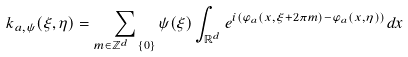Convert formula to latex. <formula><loc_0><loc_0><loc_500><loc_500>k _ { a , \psi } ( \xi , \eta ) = \sum _ { m \in \mathbb { Z } ^ { d } \ \{ 0 \} } \psi ( \xi ) \int _ { \mathbb { R } ^ { d } } e ^ { i ( \varphi _ { a } ( x , \xi + 2 \pi m ) - \varphi _ { a } ( x , \eta ) ) } d x</formula> 